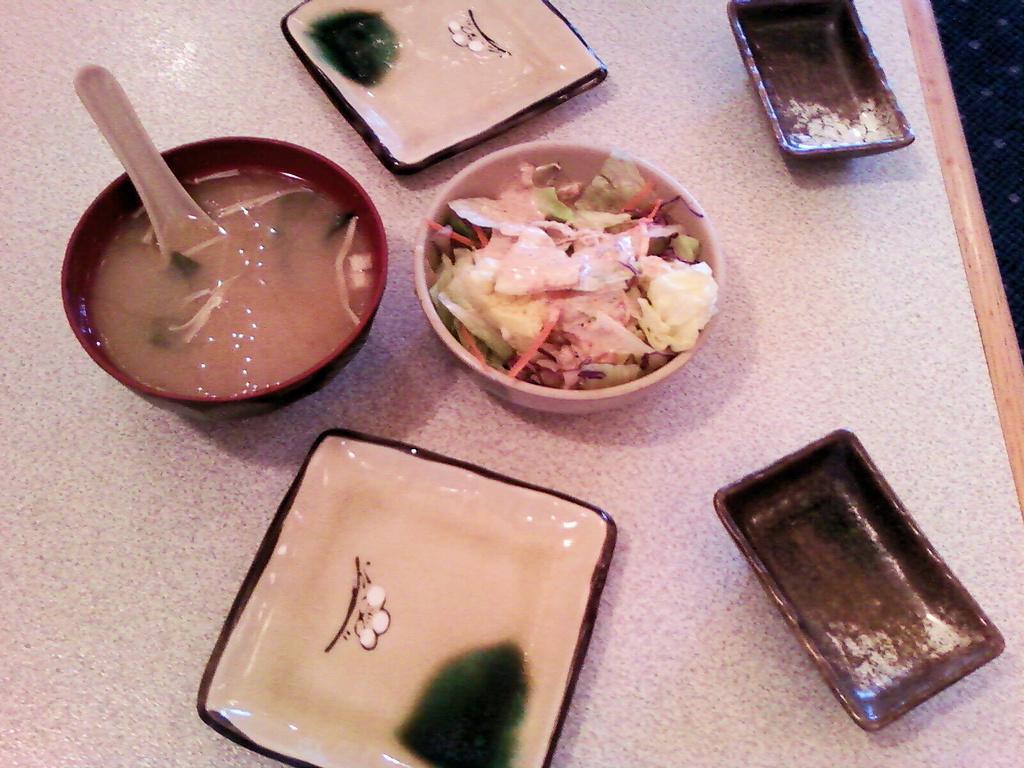In one or two sentences, can you explain what this image depicts? This image consists of bowls in which we can see a soup and salad, which are kept on the table. 